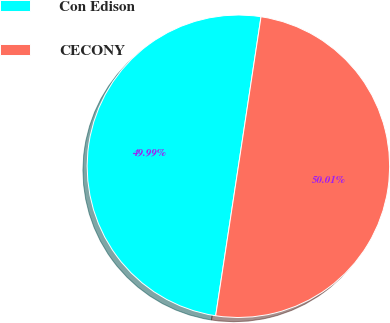<chart> <loc_0><loc_0><loc_500><loc_500><pie_chart><fcel>Con Edison<fcel>CECONY<nl><fcel>49.99%<fcel>50.01%<nl></chart> 